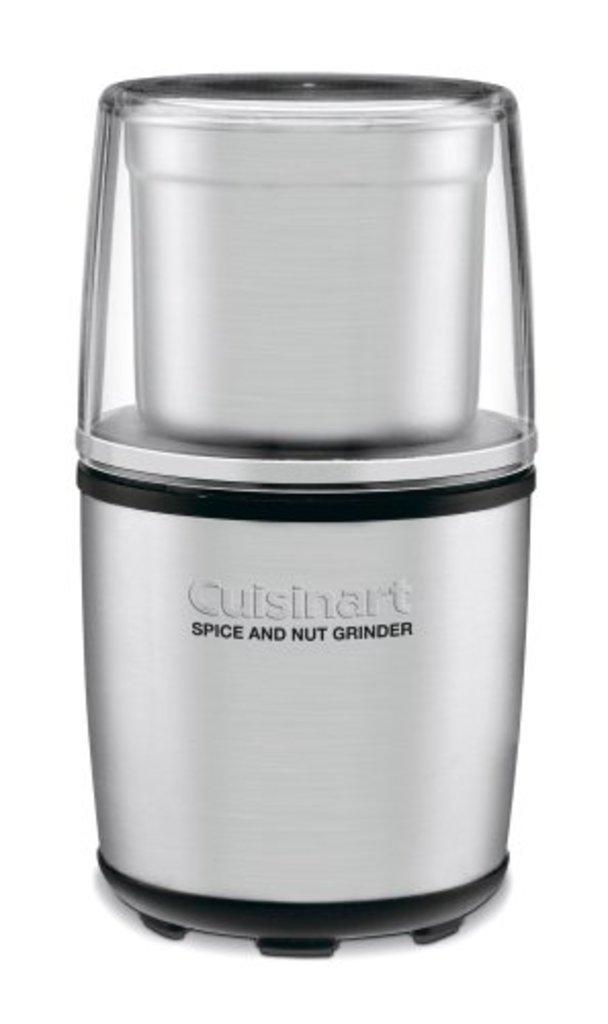In one or two sentences, can you explain what this image depicts? In this picture I can see there is a grinder and it is placed on a white surface and it has a logo printed on it. 